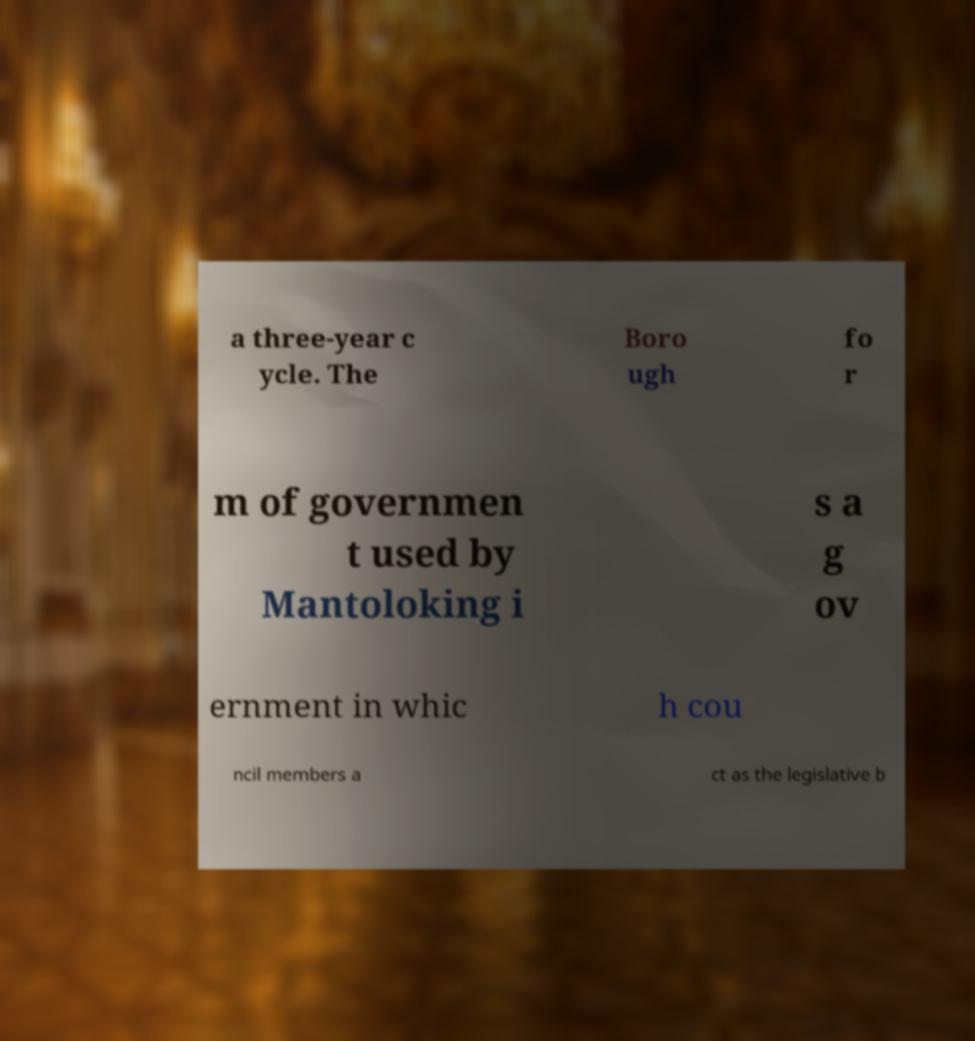I need the written content from this picture converted into text. Can you do that? a three-year c ycle. The Boro ugh fo r m of governmen t used by Mantoloking i s a g ov ernment in whic h cou ncil members a ct as the legislative b 